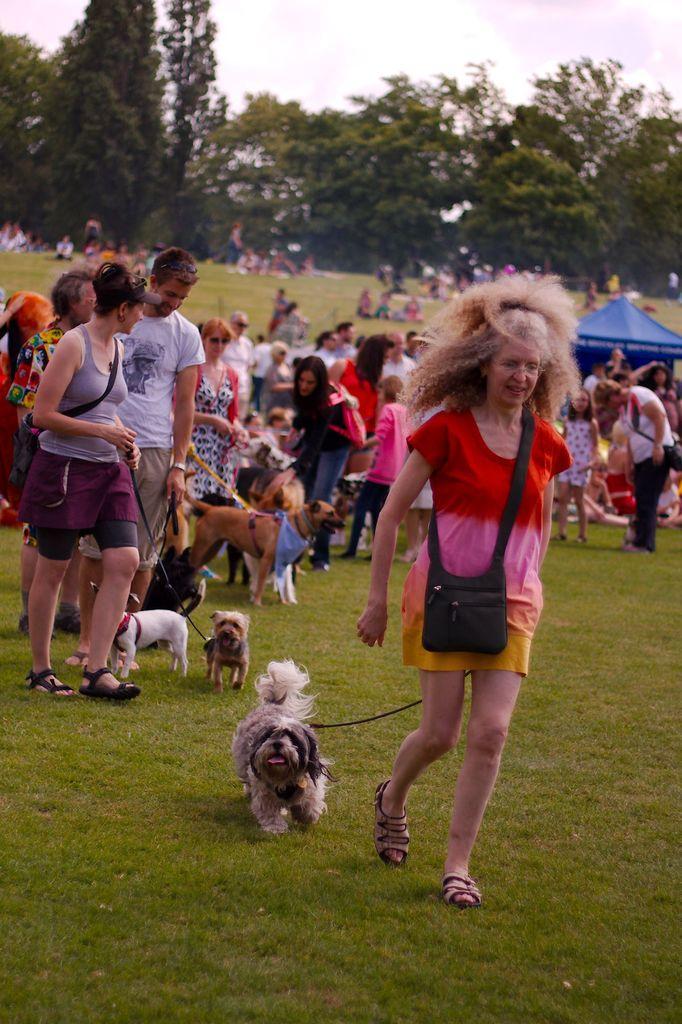Please provide a concise description of this image. This picture shows few people seated on the ground and few are standing and holding Dogs with the help of strings and we see a tent and grass on the ground and the few of them were handbags and a cloudy Sky and we see trees. 